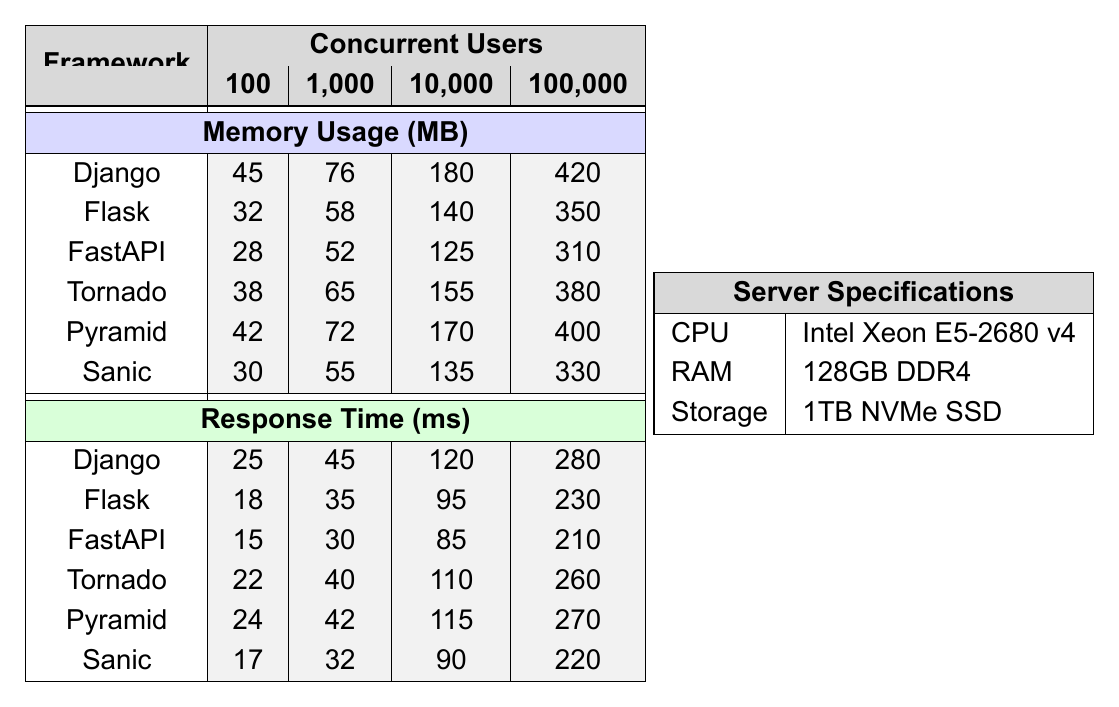What is the memory usage of Django with 10,000 concurrent users? According to the table, the memory usage for Django with 10,000 concurrent users is 180 MB.
Answer: 180 MB Which framework has the lowest memory usage at 100 concurrent users? The table shows that FastAPI has the lowest memory usage at 100 concurrent users with a value of 28 MB.
Answer: 28 MB What is the difference in memory usage between Flask and Sanic at 1,000 concurrent users? For Flask, the memory usage at 1,000 concurrent users is 58 MB, while for Sanic, it is 55 MB. The difference is calculated as 58 MB - 55 MB = 3 MB.
Answer: 3 MB Which framework demonstrates the best response time at 100,000 concurrent users? By reviewing the response time data for 100,000 concurrent users, FastAPI has the best response time of 210 ms.
Answer: 210 ms Is it true that Tornado uses more memory than Flask at 10,000 concurrent users? The table indicates that Tornado uses 155 MB while Flask uses 140 MB for 10,000 concurrent users. Therefore, the statement is true.
Answer: Yes What is the average memory usage of all frameworks at 100 concurrent users? The memory usages at 100 concurrent users are 45 (Django) + 32 (Flask) + 28 (FastAPI) + 38 (Tornado) + 42 (Pyramid) + 30 (Sanic) = 215 MB. There are 6 frameworks, so the average is 215 MB / 6 = approximately 35.83 MB.
Answer: Approximately 35.83 MB How does the response time of Pyramid at 1,000 concurrent users compare to that of Django at the same user count? The response time for Pyramid at 1,000 concurrent users is 42 ms, while for Django it is 45 ms. Pyramid's response time is shorter by 3 ms.
Answer: Pyramid’s response time is shorter by 3 ms What is the total memory usage of all frameworks at 100,000 concurrent users? At 100,000 concurrent users, the memory usages are: Django (420) + Flask (350) + FastAPI (310) + Tornado (380) + Pyramid (400) + Sanic (330) = 2190 MB.
Answer: 2190 MB Which framework has the highest response time at any level of concurrent users? Reviewing the response time for all levels of concurrent users, Django has the highest response time at 100,000 concurrent users with 280 ms.
Answer: Django What is the trend in memory usage as the number of concurrent users increases? Analyzing the data shows that memory usage consistently increases as concurrent users increase across all frameworks.
Answer: Memory usage increases with concurrent users 